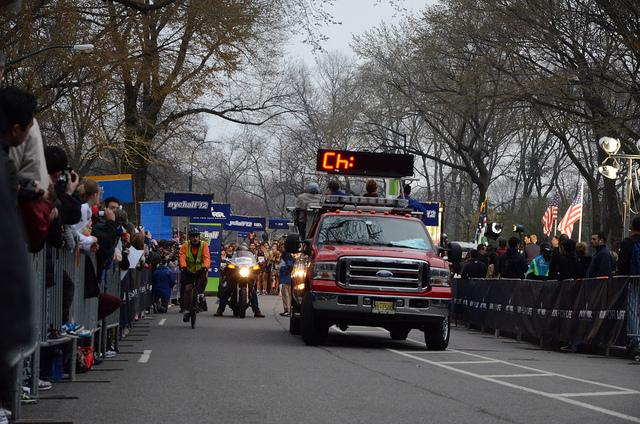What is the person in the left corner doing?
Be succinct. Watching. How many flags can you see?
Write a very short answer. 2. Where is the motorcycle?
Short answer required. Behind truck. Is this a race?
Give a very brief answer. Yes. Are both people on the motorcycle wearing helmets?
Answer briefly. No. What is the photo taken in the US?
Answer briefly. Yes. Is there a bus in this picture?
Be succinct. No. What color is the truck?
Be succinct. Red. 